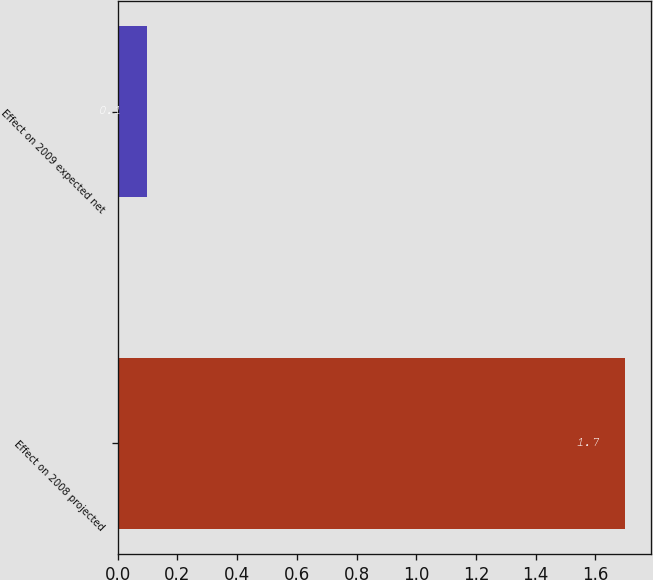<chart> <loc_0><loc_0><loc_500><loc_500><bar_chart><fcel>Effect on 2008 projected<fcel>Effect on 2009 expected net<nl><fcel>1.7<fcel>0.1<nl></chart> 